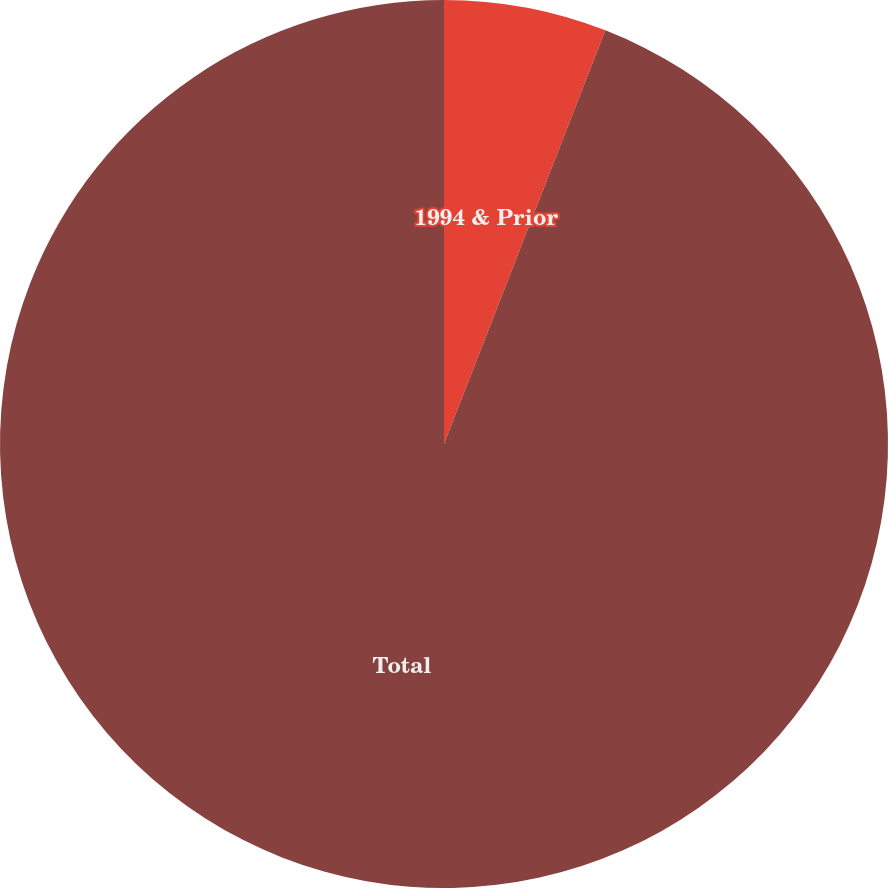Convert chart to OTSL. <chart><loc_0><loc_0><loc_500><loc_500><pie_chart><fcel>1994 & Prior<fcel>Total<nl><fcel>5.92%<fcel>94.08%<nl></chart> 